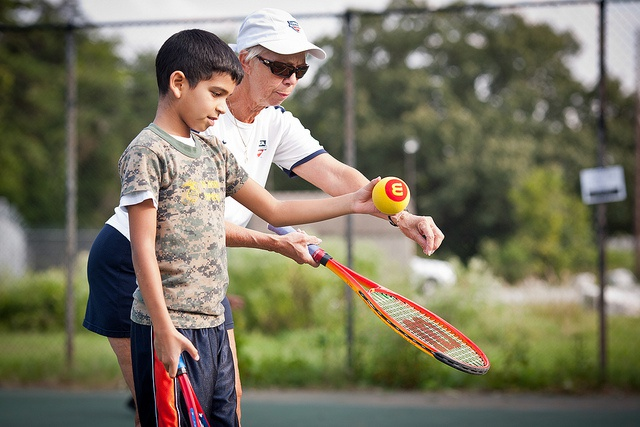Describe the objects in this image and their specific colors. I can see people in black, lightgray, darkgray, and brown tones, people in black, white, brown, and lightpink tones, tennis racket in black, olive, lightgray, salmon, and red tones, car in black, lightgray, darkgray, and gray tones, and sports ball in black, orange, red, khaki, and gold tones in this image. 